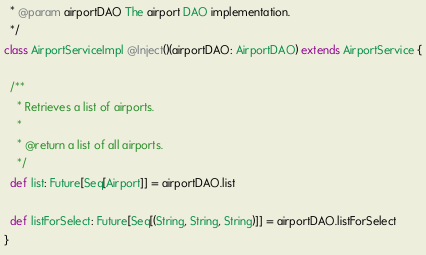Convert code to text. <code><loc_0><loc_0><loc_500><loc_500><_Scala_>  * @param airportDAO The airport DAO implementation.
  */
class AirportServiceImpl @Inject()(airportDAO: AirportDAO) extends AirportService {

  /**
    * Retrieves a list of airports.
    *
    * @return a list of all airports.
    */
  def list: Future[Seq[Airport]] = airportDAO.list

  def listForSelect: Future[Seq[(String, String, String)]] = airportDAO.listForSelect
}
</code> 